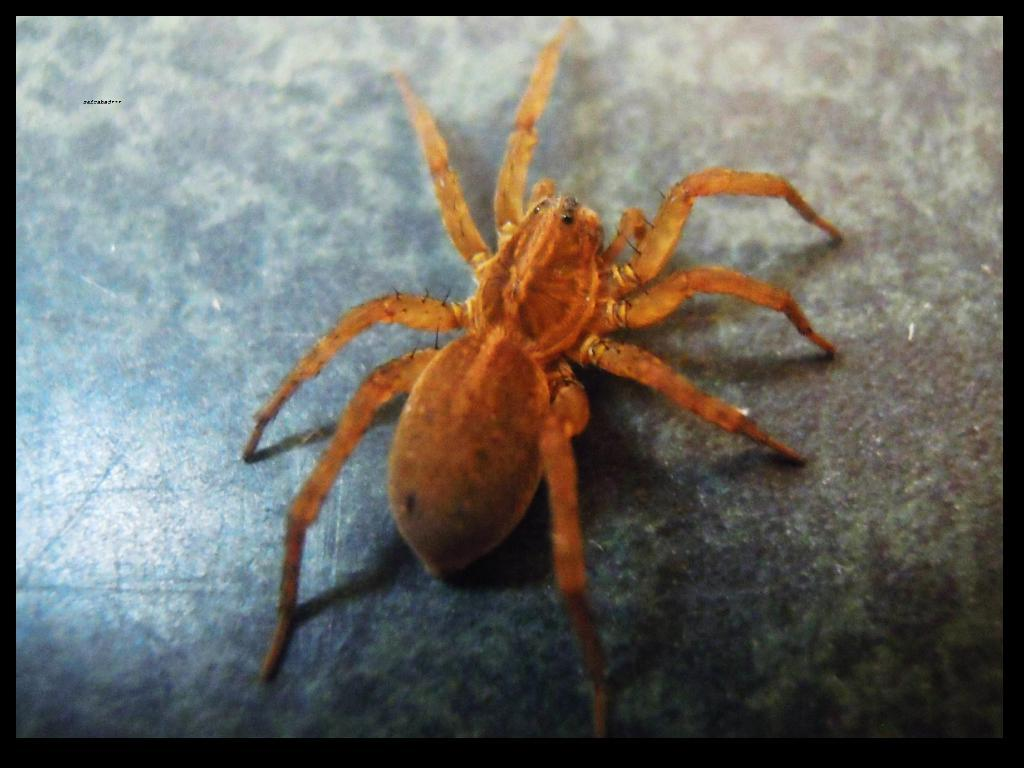What is the main subject of the image? There is a spider in the image. Where is the spider located? The spider is on a table. What color is the spider? The spider is orange in color. What type of footwear is the spider wearing in the image? There is no footwear present in the image, as spiders do not wear footwear. 